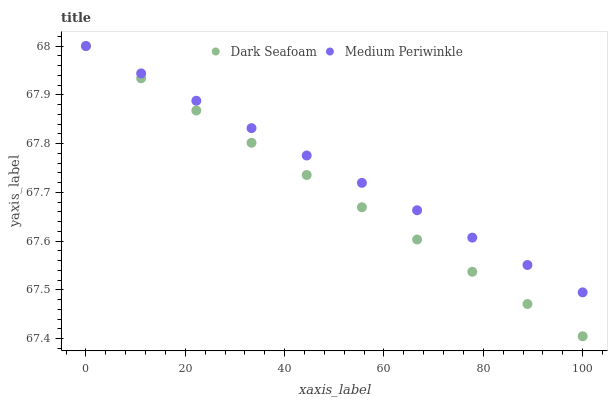Does Dark Seafoam have the minimum area under the curve?
Answer yes or no. Yes. Does Medium Periwinkle have the maximum area under the curve?
Answer yes or no. Yes. Does Medium Periwinkle have the minimum area under the curve?
Answer yes or no. No. Is Dark Seafoam the smoothest?
Answer yes or no. Yes. Is Medium Periwinkle the roughest?
Answer yes or no. Yes. Is Medium Periwinkle the smoothest?
Answer yes or no. No. Does Dark Seafoam have the lowest value?
Answer yes or no. Yes. Does Medium Periwinkle have the lowest value?
Answer yes or no. No. Does Medium Periwinkle have the highest value?
Answer yes or no. Yes. Does Dark Seafoam intersect Medium Periwinkle?
Answer yes or no. Yes. Is Dark Seafoam less than Medium Periwinkle?
Answer yes or no. No. Is Dark Seafoam greater than Medium Periwinkle?
Answer yes or no. No. 